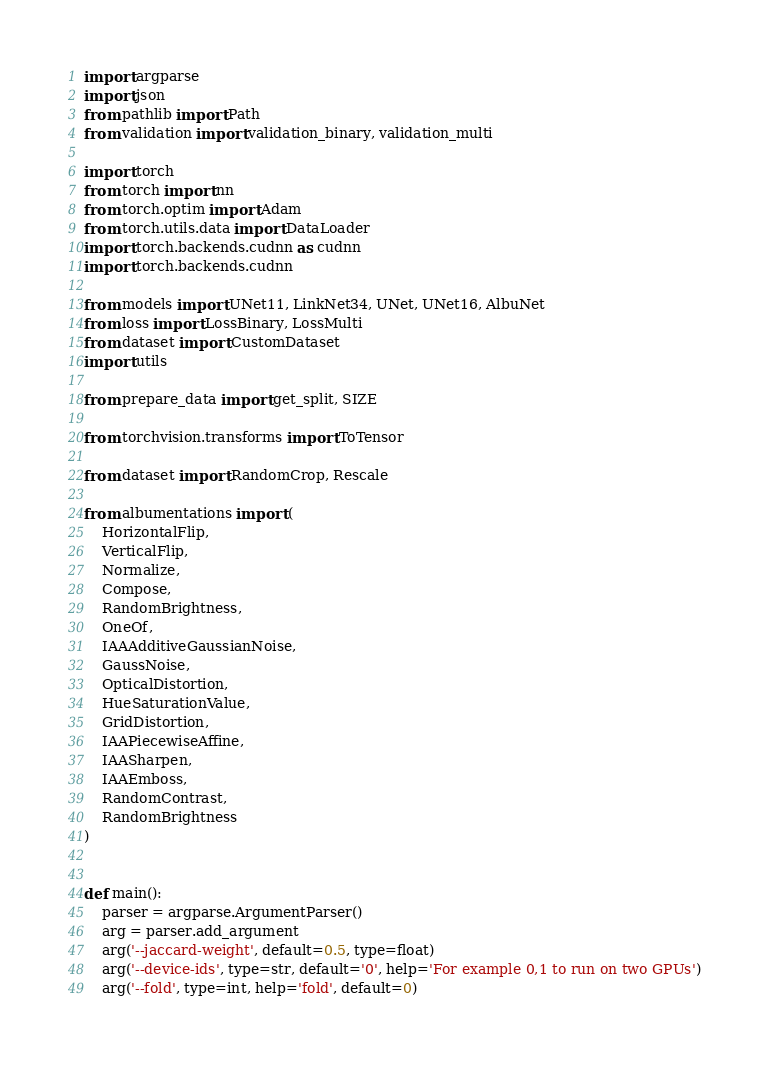<code> <loc_0><loc_0><loc_500><loc_500><_Python_>import argparse
import json
from pathlib import Path
from validation import validation_binary, validation_multi

import torch
from torch import nn
from torch.optim import Adam
from torch.utils.data import DataLoader
import torch.backends.cudnn as cudnn
import torch.backends.cudnn

from models import UNet11, LinkNet34, UNet, UNet16, AlbuNet
from loss import LossBinary, LossMulti
from dataset import CustomDataset
import utils

from prepare_data import get_split, SIZE

from torchvision.transforms import ToTensor

from dataset import RandomCrop, Rescale

from albumentations import (
    HorizontalFlip,
    VerticalFlip,
    Normalize,
    Compose,
    RandomBrightness,
    OneOf,
    IAAAdditiveGaussianNoise,
    GaussNoise,
    OpticalDistortion,
    HueSaturationValue,
    GridDistortion,
    IAAPiecewiseAffine,
    IAASharpen,
    IAAEmboss,
    RandomContrast,
    RandomBrightness
)


def main():
    parser = argparse.ArgumentParser()
    arg = parser.add_argument
    arg('--jaccard-weight', default=0.5, type=float)
    arg('--device-ids', type=str, default='0', help='For example 0,1 to run on two GPUs')
    arg('--fold', type=int, help='fold', default=0)</code> 